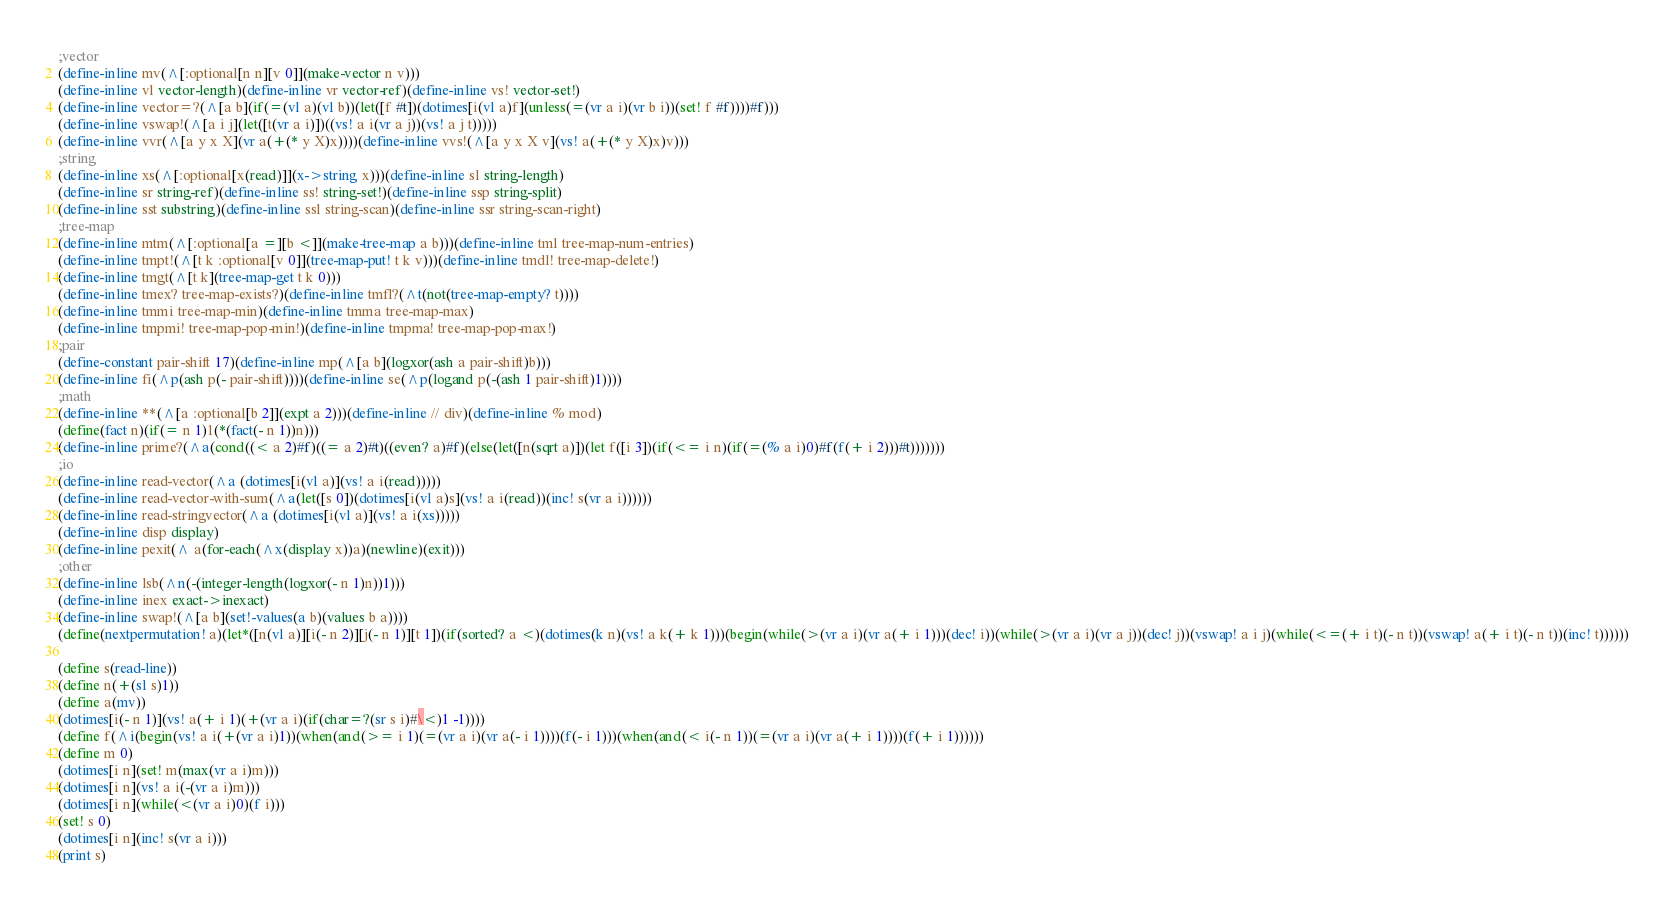Convert code to text. <code><loc_0><loc_0><loc_500><loc_500><_Scheme_>;vector
(define-inline mv(^[:optional[n n][v 0]](make-vector n v)))
(define-inline vl vector-length)(define-inline vr vector-ref)(define-inline vs! vector-set!)
(define-inline vector=?(^[a b](if(=(vl a)(vl b))(let([f #t])(dotimes[i(vl a)f](unless(=(vr a i)(vr b i))(set! f #f))))#f)))
(define-inline vswap!(^[a i j](let([t(vr a i)])((vs! a i(vr a j))(vs! a j t)))))
(define-inline vvr(^[a y x X](vr a(+(* y X)x))))(define-inline vvs!(^[a y x X v](vs! a(+(* y X)x)v)))
;string
(define-inline xs(^[:optional[x(read)]](x->string x)))(define-inline sl string-length)
(define-inline sr string-ref)(define-inline ss! string-set!)(define-inline ssp string-split)
(define-inline sst substring)(define-inline ssl string-scan)(define-inline ssr string-scan-right)
;tree-map
(define-inline mtm(^[:optional[a =][b <]](make-tree-map a b)))(define-inline tml tree-map-num-entries)
(define-inline tmpt!(^[t k :optional[v 0]](tree-map-put! t k v)))(define-inline tmdl! tree-map-delete!)
(define-inline tmgt(^[t k](tree-map-get t k 0)))
(define-inline tmex? tree-map-exists?)(define-inline tmfl?(^t(not(tree-map-empty? t))))
(define-inline tmmi tree-map-min)(define-inline tmma tree-map-max)
(define-inline tmpmi! tree-map-pop-min!)(define-inline tmpma! tree-map-pop-max!)
;pair
(define-constant pair-shift 17)(define-inline mp(^[a b](logxor(ash a pair-shift)b)))
(define-inline fi(^p(ash p(- pair-shift))))(define-inline se(^p(logand p(-(ash 1 pair-shift)1))))
;math
(define-inline **(^[a :optional[b 2]](expt a 2)))(define-inline // div)(define-inline % mod)
(define(fact n)(if(= n 1)1(*(fact(- n 1))n)))
(define-inline prime?(^a(cond((< a 2)#f)((= a 2)#t)((even? a)#f)(else(let([n(sqrt a)])(let f([i 3])(if(<= i n)(if(=(% a i)0)#f(f(+ i 2)))#t)))))))
;io
(define-inline read-vector(^a (dotimes[i(vl a)](vs! a i(read)))))
(define-inline read-vector-with-sum(^a(let([s 0])(dotimes[i(vl a)s](vs! a i(read))(inc! s(vr a i))))))
(define-inline read-stringvector(^a (dotimes[i(vl a)](vs! a i(xs)))))
(define-inline disp display)
(define-inline pexit(^ a(for-each(^x(display x))a)(newline)(exit)))
;other
(define-inline lsb(^n(-(integer-length(logxor(- n 1)n))1)))
(define-inline inex exact->inexact)
(define-inline swap!(^[a b](set!-values(a b)(values b a))))
(define(nextpermutation! a)(let*([n(vl a)][i(- n 2)][j(- n 1)][t 1])(if(sorted? a <)(dotimes(k n)(vs! a k(+ k 1)))(begin(while(>(vr a i)(vr a(+ i 1)))(dec! i))(while(>(vr a i)(vr a j))(dec! j))(vswap! a i j)(while(<=(+ i t)(- n t))(vswap! a(+ i t)(- n t))(inc! t))))))

(define s(read-line))
(define n(+(sl s)1))
(define a(mv))
(dotimes[i(- n 1)](vs! a(+ i 1)(+(vr a i)(if(char=?(sr s i)#\<)1 -1))))
(define f(^i(begin(vs! a i(+(vr a i)1))(when(and(>= i 1)(=(vr a i)(vr a(- i 1))))(f(- i 1)))(when(and(< i(- n 1))(=(vr a i)(vr a(+ i 1))))(f(+ i 1))))))
(define m 0)
(dotimes[i n](set! m(max(vr a i)m)))
(dotimes[i n](vs! a i(-(vr a i)m)))
(dotimes[i n](while(<(vr a i)0)(f i)))
(set! s 0)
(dotimes[i n](inc! s(vr a i)))
(print s)</code> 